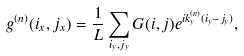<formula> <loc_0><loc_0><loc_500><loc_500>g ^ { ( n ) } ( i _ { x } , j _ { x } ) = \frac { 1 } { L } \sum _ { i _ { y } , j _ { y } } G ( i , j ) e ^ { i k _ { y } ^ { ( n ) } ( i _ { y } - j _ { y } ) } ,</formula> 